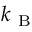<formula> <loc_0><loc_0><loc_500><loc_500>k _ { B }</formula> 